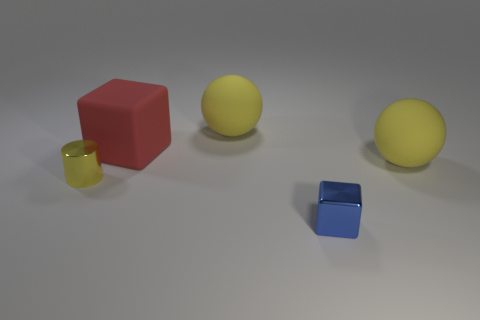What number of things are large yellow rubber things or yellow spheres right of the small metal cube? There are two objects that fit the description: one large yellow rubber ducky and one yellow sphere, both situated to the right of the small metal cube. 